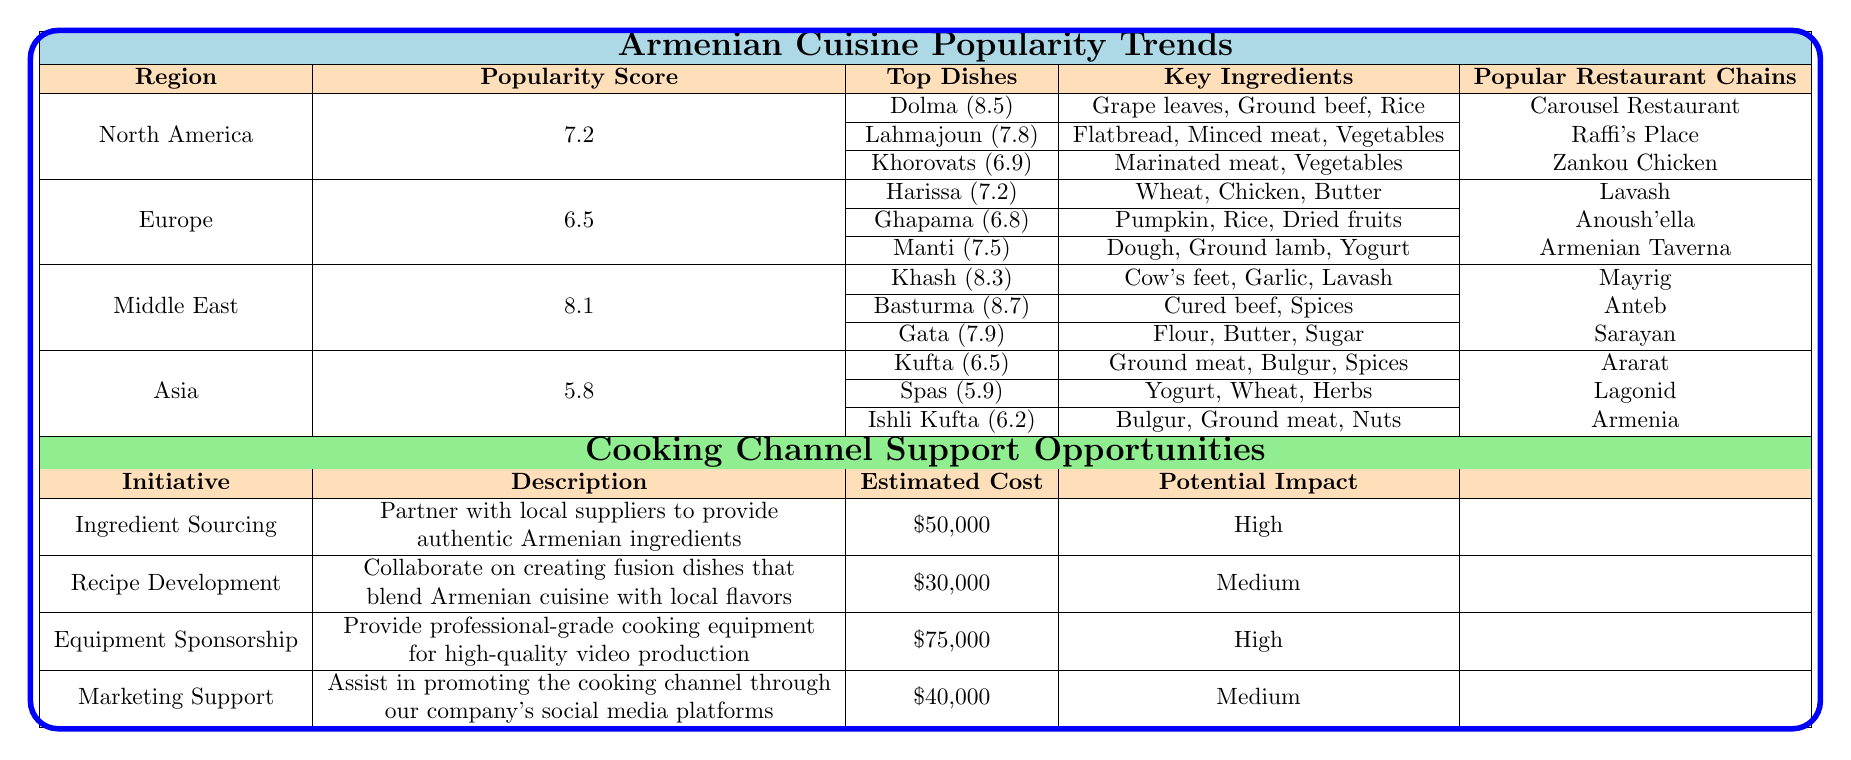What is the popularity score for Armenian cuisine in North America? According to the table, the popularity score for North America is listed directly under the corresponding region, which is 7.2.
Answer: 7.2 Which dish has the highest popularity score in the Middle East? From the Middle East section, the dish Basturma has the highest popularity score at 8.7 as shown in the table.
Answer: 8.7 How many popular restaurant chains are listed for Europe? The table shows that there are three popular restaurant chains listed for Europe: Lavash, Anoush'ella, and Armenian Taverna.
Answer: 3 What are the key ingredients for the dish Dolma? The key ingredients for Dolma, as stated in the North America section, are grape leaves, ground beef, and rice.
Answer: Grape leaves, ground beef, rice Which region has the highest overall popularity score for Armenian cuisine? By comparing the popularity scores in the table, the Middle East has the highest score at 8.1, which is greater than North America (7.2), Europe (6.5), and Asia (5.8).
Answer: Middle East What is the average popularity score for all the regions listed? The average popularity score can be calculated by summing the scores (7.2 + 6.5 + 8.1 + 5.8) = 27.6, then dividing by the number of regions (4), resulting in an average of 27.6 / 4 = 6.9.
Answer: 6.9 Is there a dish from Asia with a popularity score above 6? Looking at the Asia section, the dishes Kufta (6.5) and Ishli Kufta (6.2) have scores, but only Kufta's score is above 6. Therefore, the answer is yes.
Answer: Yes What initiatives have a high potential impact among the cooking channel support opportunities? The initiatives Ingredient Sourcing and Equipment Sponsorship both have a potential impact categorized as High in the table, indicating their importance.
Answer: Ingredient Sourcing, Equipment Sponsorship What are the key ingredients for the dish Manti? The table indicates that the key ingredients for Manti include dough, ground lamb, and yogurt, as listed in the Europe section.
Answer: Dough, ground lamb, yogurt Which region has the lowest popularity score and what is that score? By examining the popularity scores, Asia has the lowest score of 5.8 compared to other regions.
Answer: 5.8 How much does it cost for the Marketing Support initiative? The estimated cost for the Marketing Support initiative is listed in the table as $40,000, indicating the financial requirement for this initiative.
Answer: $40,000 